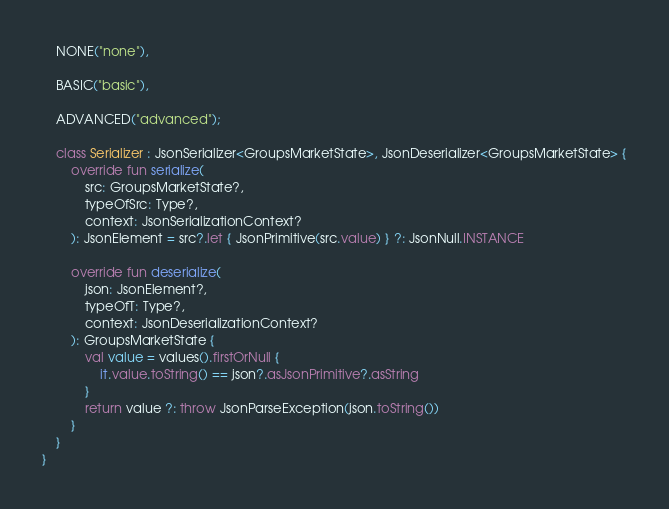Convert code to text. <code><loc_0><loc_0><loc_500><loc_500><_Kotlin_>    NONE("none"),

    BASIC("basic"),

    ADVANCED("advanced");

    class Serializer : JsonSerializer<GroupsMarketState>, JsonDeserializer<GroupsMarketState> {
        override fun serialize(
            src: GroupsMarketState?,
            typeOfSrc: Type?,
            context: JsonSerializationContext?
        ): JsonElement = src?.let { JsonPrimitive(src.value) } ?: JsonNull.INSTANCE

        override fun deserialize(
            json: JsonElement?,
            typeOfT: Type?,
            context: JsonDeserializationContext?
        ): GroupsMarketState {
            val value = values().firstOrNull {
                it.value.toString() == json?.asJsonPrimitive?.asString
            }
            return value ?: throw JsonParseException(json.toString())
        }
    }
}
</code> 